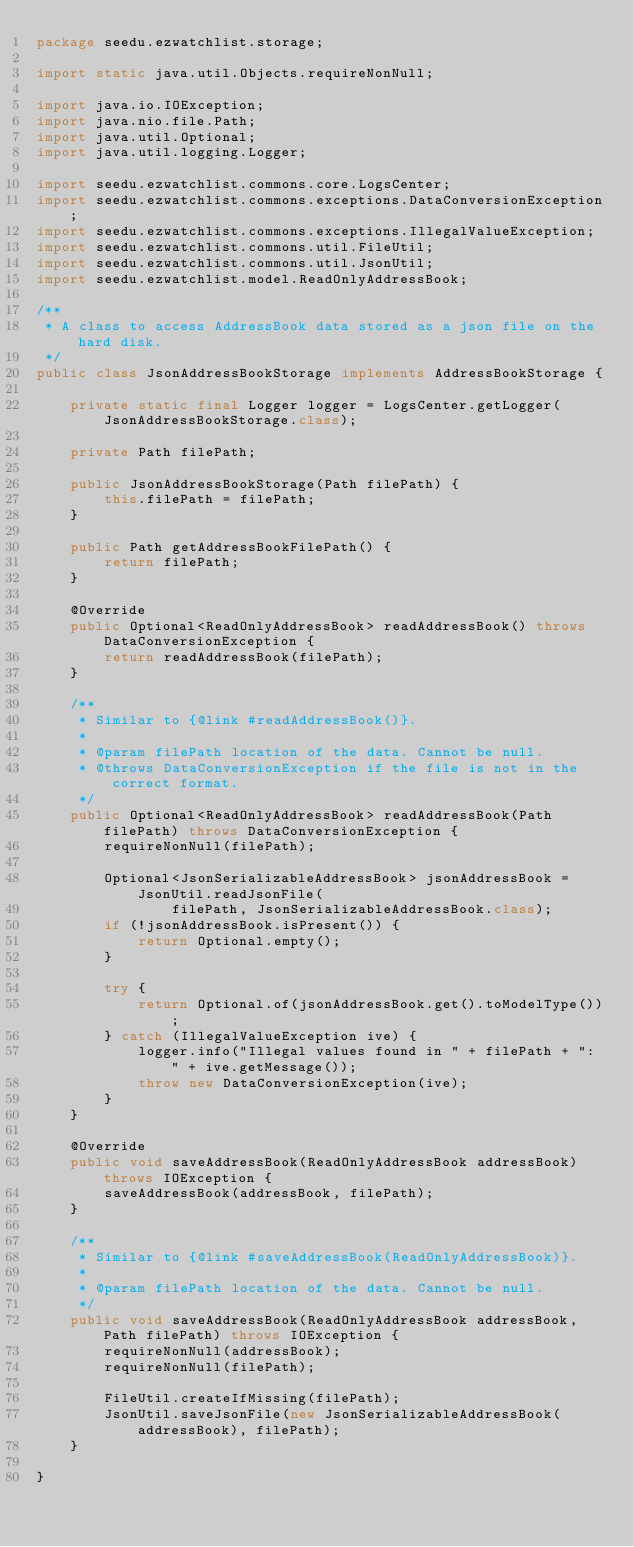Convert code to text. <code><loc_0><loc_0><loc_500><loc_500><_Java_>package seedu.ezwatchlist.storage;

import static java.util.Objects.requireNonNull;

import java.io.IOException;
import java.nio.file.Path;
import java.util.Optional;
import java.util.logging.Logger;

import seedu.ezwatchlist.commons.core.LogsCenter;
import seedu.ezwatchlist.commons.exceptions.DataConversionException;
import seedu.ezwatchlist.commons.exceptions.IllegalValueException;
import seedu.ezwatchlist.commons.util.FileUtil;
import seedu.ezwatchlist.commons.util.JsonUtil;
import seedu.ezwatchlist.model.ReadOnlyAddressBook;

/**
 * A class to access AddressBook data stored as a json file on the hard disk.
 */
public class JsonAddressBookStorage implements AddressBookStorage {

    private static final Logger logger = LogsCenter.getLogger(JsonAddressBookStorage.class);

    private Path filePath;

    public JsonAddressBookStorage(Path filePath) {
        this.filePath = filePath;
    }

    public Path getAddressBookFilePath() {
        return filePath;
    }

    @Override
    public Optional<ReadOnlyAddressBook> readAddressBook() throws DataConversionException {
        return readAddressBook(filePath);
    }

    /**
     * Similar to {@link #readAddressBook()}.
     *
     * @param filePath location of the data. Cannot be null.
     * @throws DataConversionException if the file is not in the correct format.
     */
    public Optional<ReadOnlyAddressBook> readAddressBook(Path filePath) throws DataConversionException {
        requireNonNull(filePath);

        Optional<JsonSerializableAddressBook> jsonAddressBook = JsonUtil.readJsonFile(
                filePath, JsonSerializableAddressBook.class);
        if (!jsonAddressBook.isPresent()) {
            return Optional.empty();
        }

        try {
            return Optional.of(jsonAddressBook.get().toModelType());
        } catch (IllegalValueException ive) {
            logger.info("Illegal values found in " + filePath + ": " + ive.getMessage());
            throw new DataConversionException(ive);
        }
    }

    @Override
    public void saveAddressBook(ReadOnlyAddressBook addressBook) throws IOException {
        saveAddressBook(addressBook, filePath);
    }

    /**
     * Similar to {@link #saveAddressBook(ReadOnlyAddressBook)}.
     *
     * @param filePath location of the data. Cannot be null.
     */
    public void saveAddressBook(ReadOnlyAddressBook addressBook, Path filePath) throws IOException {
        requireNonNull(addressBook);
        requireNonNull(filePath);

        FileUtil.createIfMissing(filePath);
        JsonUtil.saveJsonFile(new JsonSerializableAddressBook(addressBook), filePath);
    }

}
</code> 